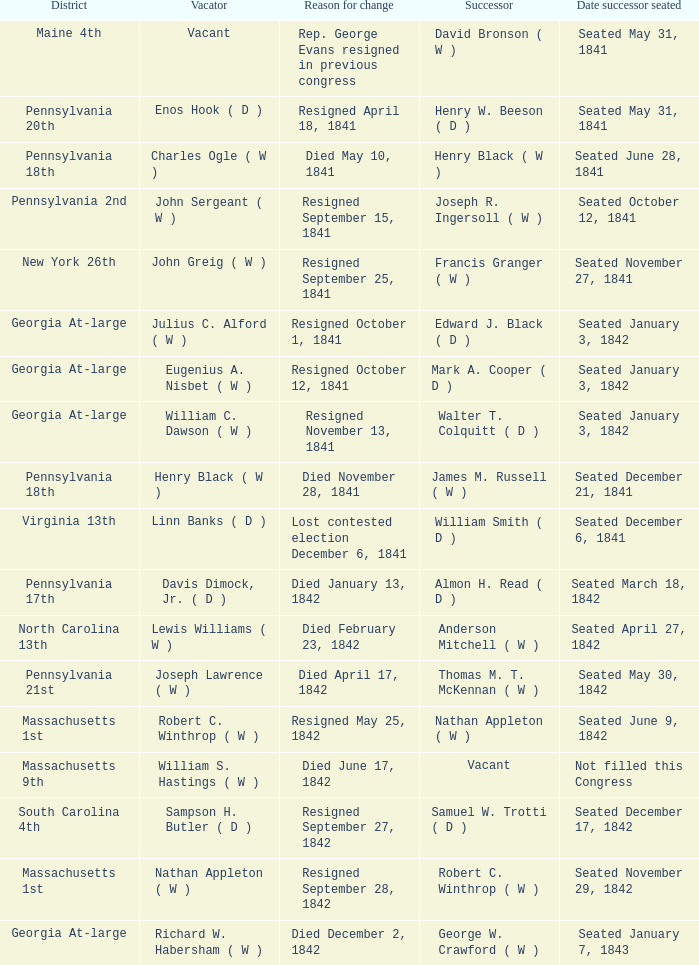Name the date successor seated for pennsylvania 17th Seated March 18, 1842. 